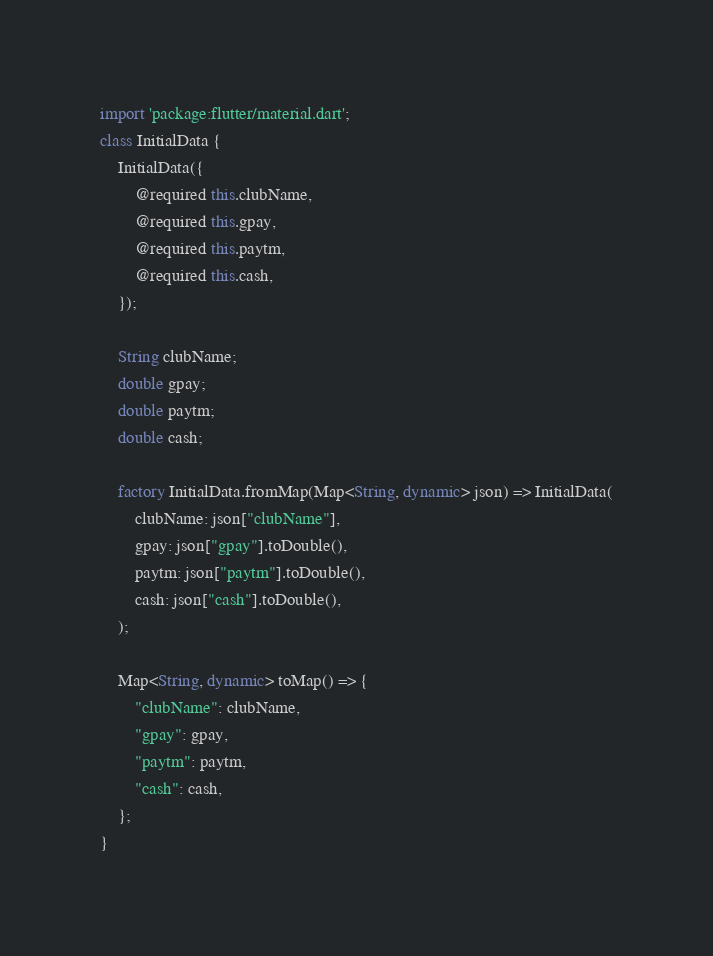<code> <loc_0><loc_0><loc_500><loc_500><_Dart_>import 'package:flutter/material.dart';
class InitialData {
    InitialData({
        @required this.clubName,
        @required this.gpay,
        @required this.paytm,
        @required this.cash,
    });

    String clubName;
    double gpay;
    double paytm;
    double cash;

    factory InitialData.fromMap(Map<String, dynamic> json) => InitialData(
        clubName: json["clubName"],
        gpay: json["gpay"].toDouble(),
        paytm: json["paytm"].toDouble(),
        cash: json["cash"].toDouble(),
    );

    Map<String, dynamic> toMap() => {
        "clubName": clubName,
        "gpay": gpay,
        "paytm": paytm,
        "cash": cash,
    };
}
</code> 